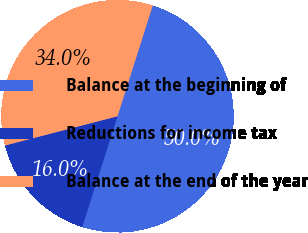<chart> <loc_0><loc_0><loc_500><loc_500><pie_chart><fcel>Balance at the beginning of<fcel>Reductions for income tax<fcel>Balance at the end of the year<nl><fcel>50.0%<fcel>16.05%<fcel>33.95%<nl></chart> 